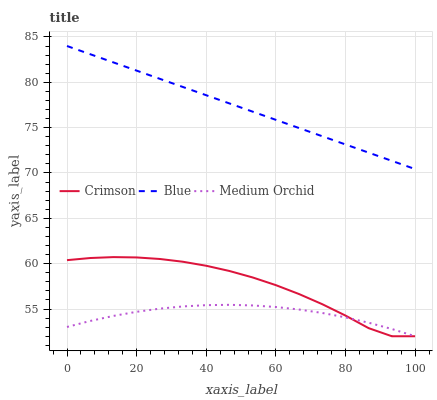Does Medium Orchid have the minimum area under the curve?
Answer yes or no. Yes. Does Blue have the maximum area under the curve?
Answer yes or no. Yes. Does Blue have the minimum area under the curve?
Answer yes or no. No. Does Medium Orchid have the maximum area under the curve?
Answer yes or no. No. Is Blue the smoothest?
Answer yes or no. Yes. Is Crimson the roughest?
Answer yes or no. Yes. Is Medium Orchid the smoothest?
Answer yes or no. No. Is Medium Orchid the roughest?
Answer yes or no. No. Does Crimson have the lowest value?
Answer yes or no. Yes. Does Medium Orchid have the lowest value?
Answer yes or no. No. Does Blue have the highest value?
Answer yes or no. Yes. Does Medium Orchid have the highest value?
Answer yes or no. No. Is Crimson less than Blue?
Answer yes or no. Yes. Is Blue greater than Medium Orchid?
Answer yes or no. Yes. Does Medium Orchid intersect Crimson?
Answer yes or no. Yes. Is Medium Orchid less than Crimson?
Answer yes or no. No. Is Medium Orchid greater than Crimson?
Answer yes or no. No. Does Crimson intersect Blue?
Answer yes or no. No. 